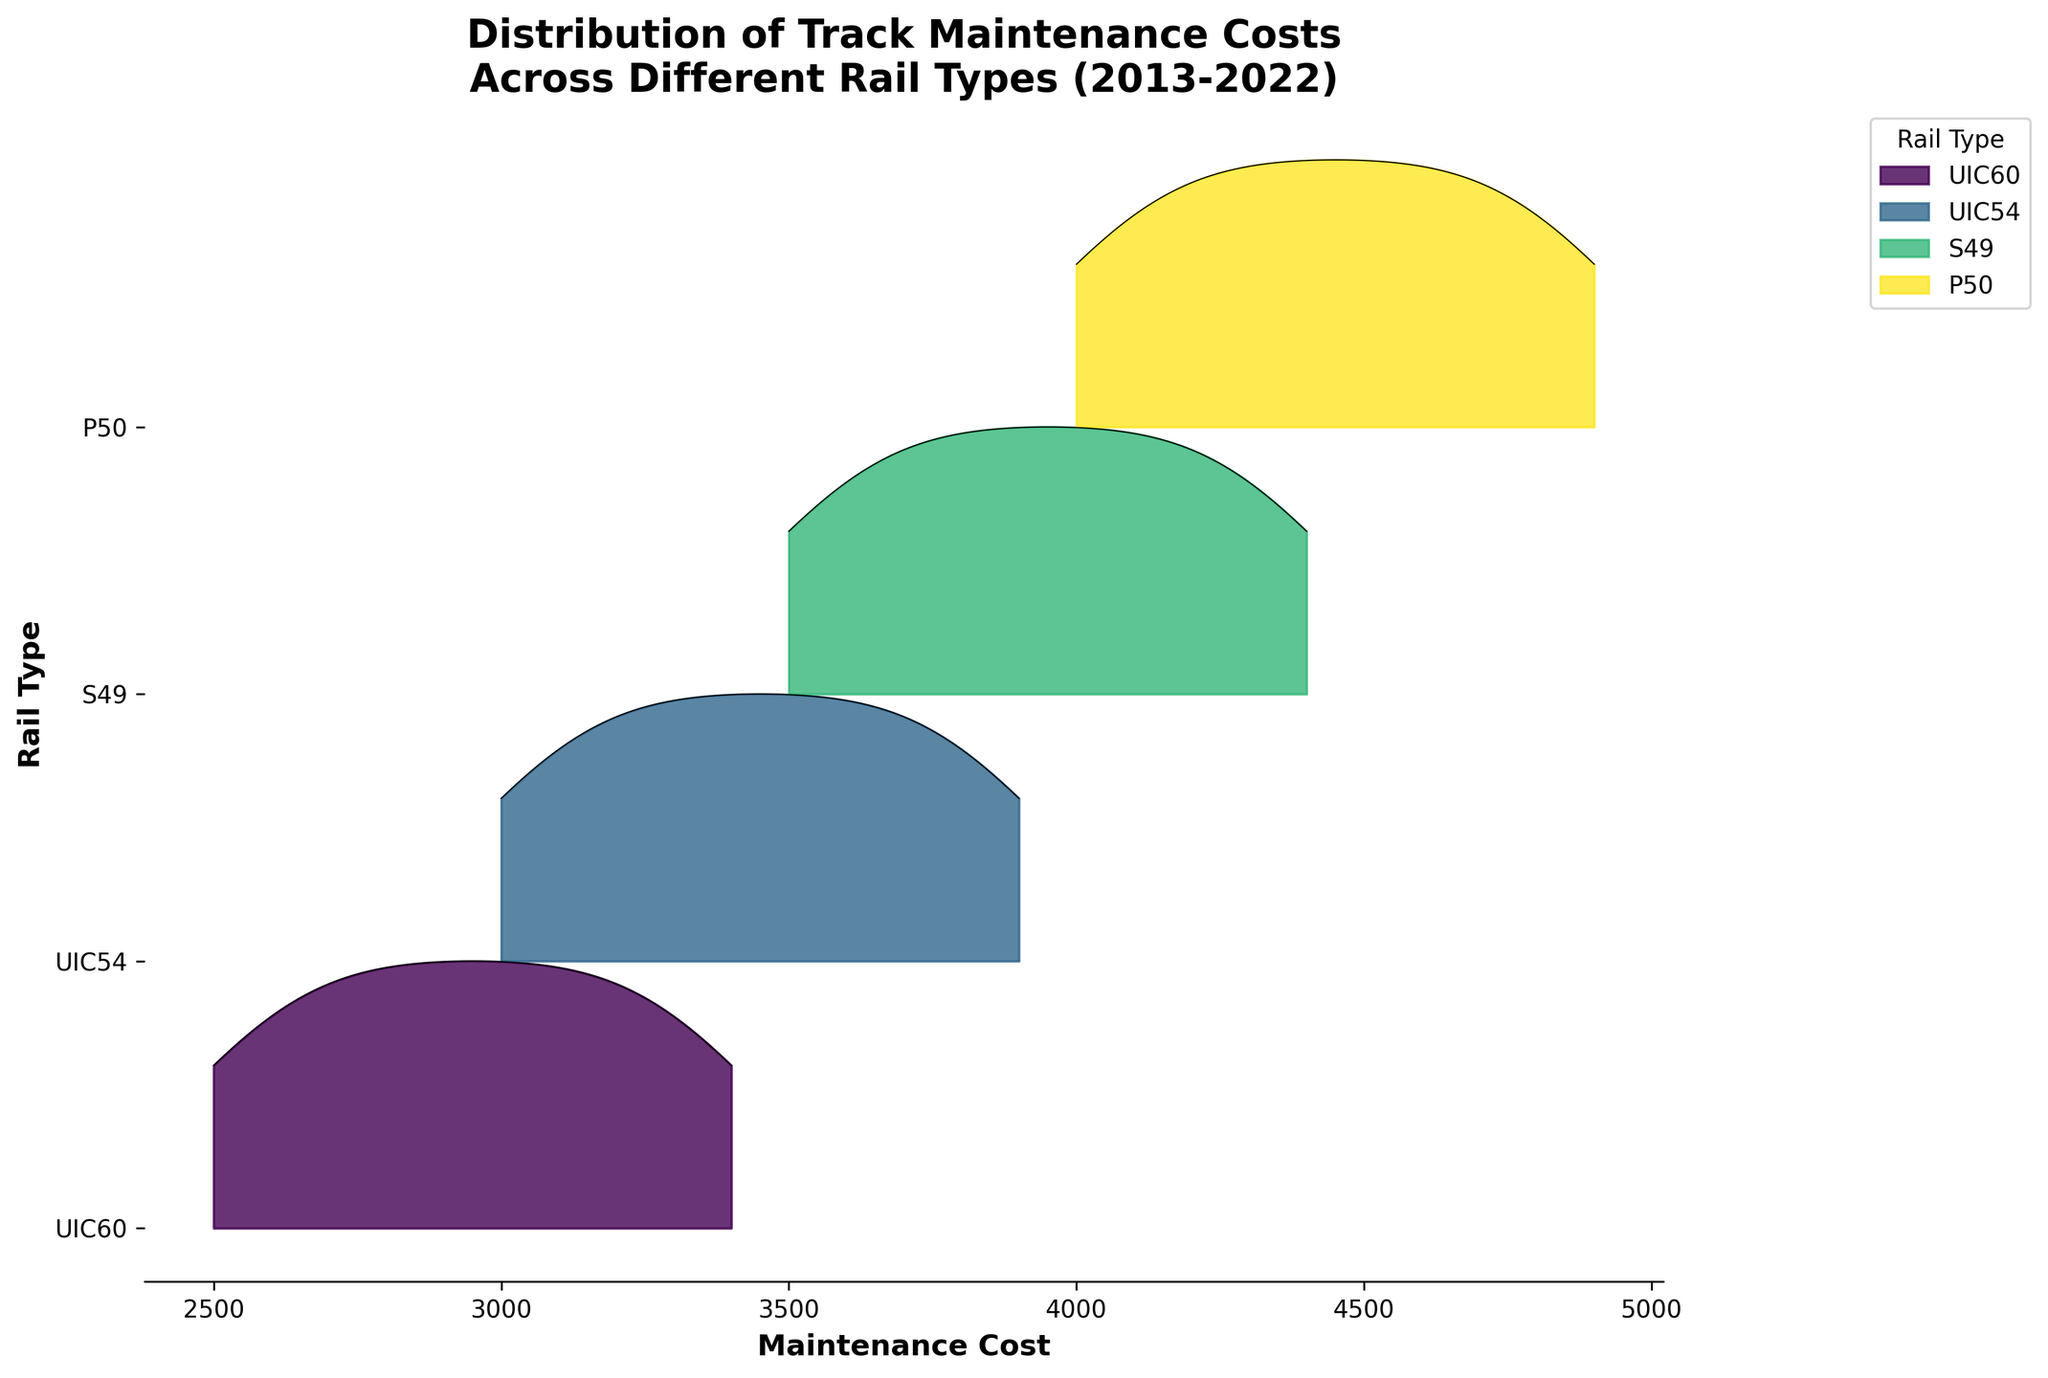What's the title of the plot? The title is usually displayed at the top of the plot, often in larger and bold fonts. Here it reads "Distribution of Track Maintenance Costs Across Different Rail Types (2013-2022)".
Answer: Distribution of Track Maintenance Costs Across Different Rail Types (2013-2022) Which rail type had the highest maintenance cost distribution in 2022? By examining the rightmost end of the ridgeline plot, where maintenance costs for 2022 are displayed, we can compare the peaks. 'P50' has the highest peak in 2022.
Answer: P50 What is the range of maintenance costs for the UIC60 rail type? To find the range, locate the UIC60 rail type along the y-axis, then identify the minimum and maximum maintenance cost along the x-axis for this rail type. The UIC60 ranges approximately from 2500 to 3400.
Answer: 2500 to 3400 Which rail type shows the most considerable variation in maintenance costs over the years? Variation can be gauged by the spread of the distribution. By comparing the width of the distributions, 'P50' shows the widest spread, indicating the most considerable variation.
Answer: P50 How does the maintenance cost distribution for S49 in 2013 compare to that in 2022? By comparing the distribution plots for S49 between 2013 (left side) and 2022 (right side), we can observe that the distribution shifts upward from 3500 to 4400, indicating an increase in costs.
Answer: S49 maintenance costs increased from 3500 to 4400 Which rail type consistently has the lowest maintenance costs? Consistency can be assessed by noting the lowest peaks across all years. 'UIC60' has the lowest maintenance costs consistently compared to other rail types.
Answer: UIC60 What trend can be observed in the maintenance costs of UIC54 rail type from 2013 to 2022? Observing the ridgeline plot from left to right for UIC54, a gradual increase is seen each year, indicating an upward trend in maintenance costs.
Answer: Upward trend Where is the maintenance cost for UIC54 in 2020 located in the plot? To find this, look at the UIC54 label along the y-axis and trace horizontally at the position corresponding to the year 2020. The value is approximately 3700.
Answer: 3700 Which rail type experienced a uniform increase in maintenance cost over the timeframe? By examining the graphs for uniform and consistent distributions shifting to the right, UIC60 and UIC54 both demonstrate uniform increases, but let's say 'UIC60' for simplicity.
Answer: UIC60 